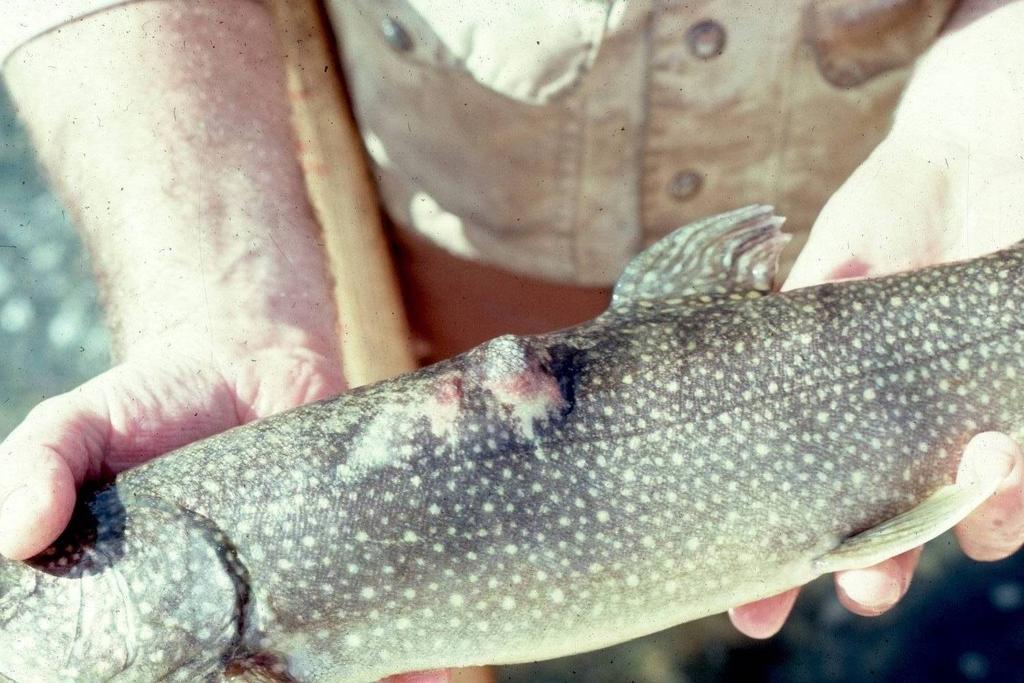Describe this image in one or two sentences. There is a person holding a fish. 